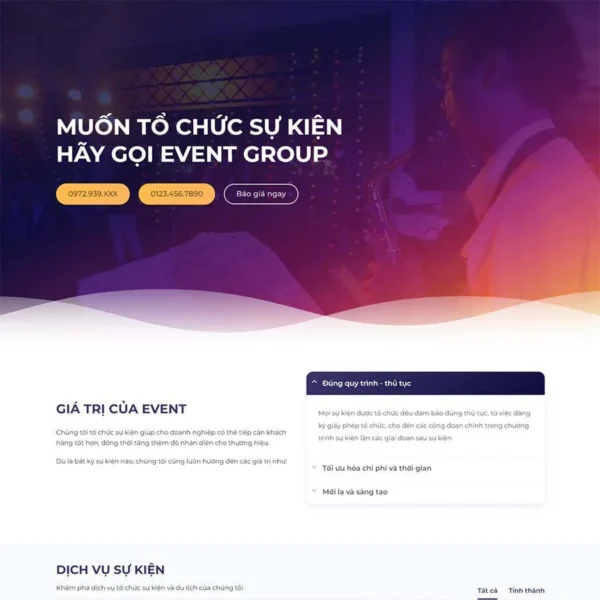Viết một bài viết giới thiệu giao diện website này của DPS MEDIA bao gồm ngành nghề, kiểu dáng, màu sắc, tính năng, bố cục,...Nhưng không nhắc lại liên kết hình ảnh trong bài viết.
 ### Giới thiệu Giao diện Website của DPS MEDIA

#### Ngành nghề
Website của DPS MEDIA thuộc lĩnh vực tổ chức sự kiện, cung cấp các dịch vụ chuyên nghiệp và sáng tạo giúp doanh nghiệp và cá nhân tổ chức các buổi sự kiện thành công và ấn tượng. Dịch vụ bao gồm tổ chức hội nghị, hội thảo, tiệc cưới, lễ kỷ niệm và nhiều loại hình sự kiện khác.

#### Kiểu dáng và màu sắc
Giao diện của trang web được thiết kế hiện đại và tinh tế với sự kết hợp màu sắc chủ đạo là xanh đậm và cam. Màu sắc này không chỉ tạo cảm giác bắt mắt mà còn giúp nhấn mạnh các yếu tố quan trọng trên trang, tạo sự thu hút đối với người dùng. Phần nền của website sử dụng hình ảnh mờ của một sự kiện, tạo nên không khí chuyên nghiệp và sinh động.

#### Tính năng
Trang web tích hợp nhiều tính năng hữu ích và tiện lợi cho người dùng, bao gồm:
- **Liên hệ nhanh**: Các số điện thoại được hiển thị nổi bật để khách hàng có thể liên hệ ngay lập tức.
- **Yêu cầu báo giá**: Nút "Báo giá ngay" giúp khách hàng dễ dàng yêu cầu báo giá trực tuyến một cách nhanh chóng.
- **Thông tin dịch vụ**: Cung cấp các thông tin chi tiết về giá trị và các gói dịch vụ của Event Group, giúp khách hàng có cái nhìn tổng quan và lựa chọn phù hợp.

#### Bố cục
Bố cục trang web được sắp xếp một cách khoa học và dễ nhìn:
- **Phần đầu trang**: Chứa thông điệp chính và các nút liên hệ nhanh, giúp thu hút sự chú ý ngay từ lần đầu truy cập.
- **Phần giữa trang**: Trình bày giá trị cốt lõi và các dịch vụ nổi bật của Event Group, kèm theo các hình ảnh minh họa và các mục tiêu của công ty.
- **Phần cuối trang**: Đưa ra các quy trình thủ tục và cam kết của công ty, nhấn mạnh vào sự tối ưu hóa chi phí và sáng tạo.

Tổng thể, giao diện website của DPS MEDIA không chỉ đẹp mắt mà còn rất tiện lợi và thân thiện với người dùng. Các yếu tố thiết kế và tính năng được tối ưu hóa để mang lại trải nghiệm tốt nhất, giúp khách hàng dễ dàng tìm kiếm thông tin và liên hệ dịch vụ một cách hiệu quả. 